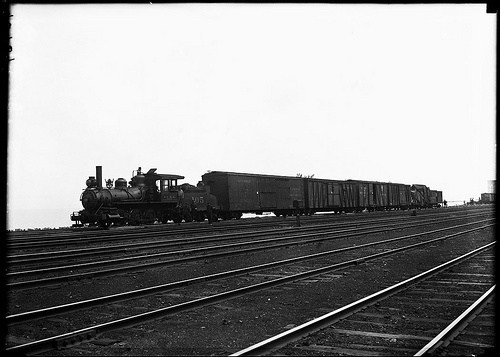Describe the objects in this image and their specific colors. I can see a train in black, gray, white, and darkgray tones in this image. 